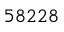<formula> <loc_0><loc_0><loc_500><loc_500>5 8 2 2 8</formula> 